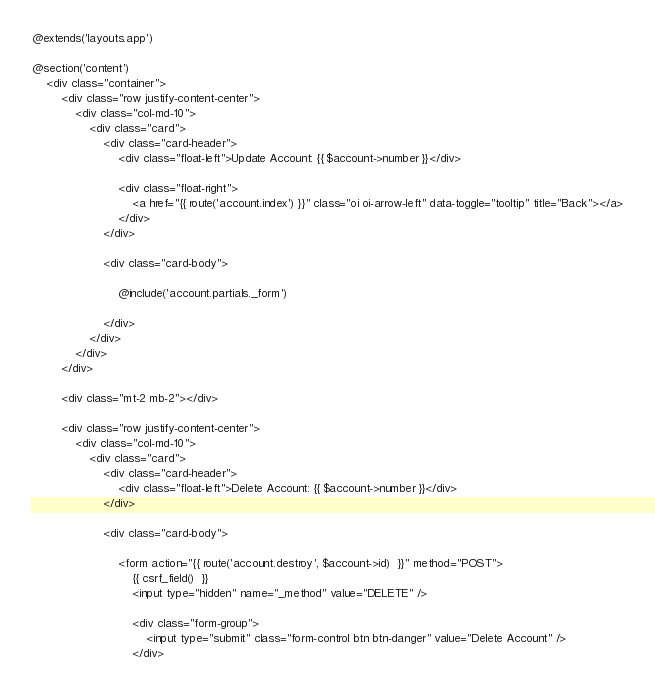Convert code to text. <code><loc_0><loc_0><loc_500><loc_500><_PHP_>@extends('layouts.app')

@section('content')
    <div class="container">
        <div class="row justify-content-center">
            <div class="col-md-10">
                <div class="card">
                    <div class="card-header">
                        <div class="float-left">Update Account: {{ $account->number }}</div>

                        <div class="float-right">
                            <a href="{{ route('account.index') }}" class="oi oi-arrow-left" data-toggle="tooltip" title="Back"></a>
                        </div>
                    </div>

                    <div class="card-body">

                        @include('account.partials._form')

                    </div>
                </div>
            </div>
        </div>

        <div class="mt-2 mb-2"></div>

        <div class="row justify-content-center">
            <div class="col-md-10">
                <div class="card">
                    <div class="card-header">
                        <div class="float-left">Delete Account: {{ $account->number }}</div>
                    </div>

                    <div class="card-body">

                        <form action="{{ route('account.destroy', $account->id)  }}" method="POST">
                            {{ csrf_field()  }}
                            <input type="hidden" name="_method" value="DELETE" />

                            <div class="form-group">
                                <input type="submit" class="form-control btn btn-danger" value="Delete Account" />
                            </div></code> 